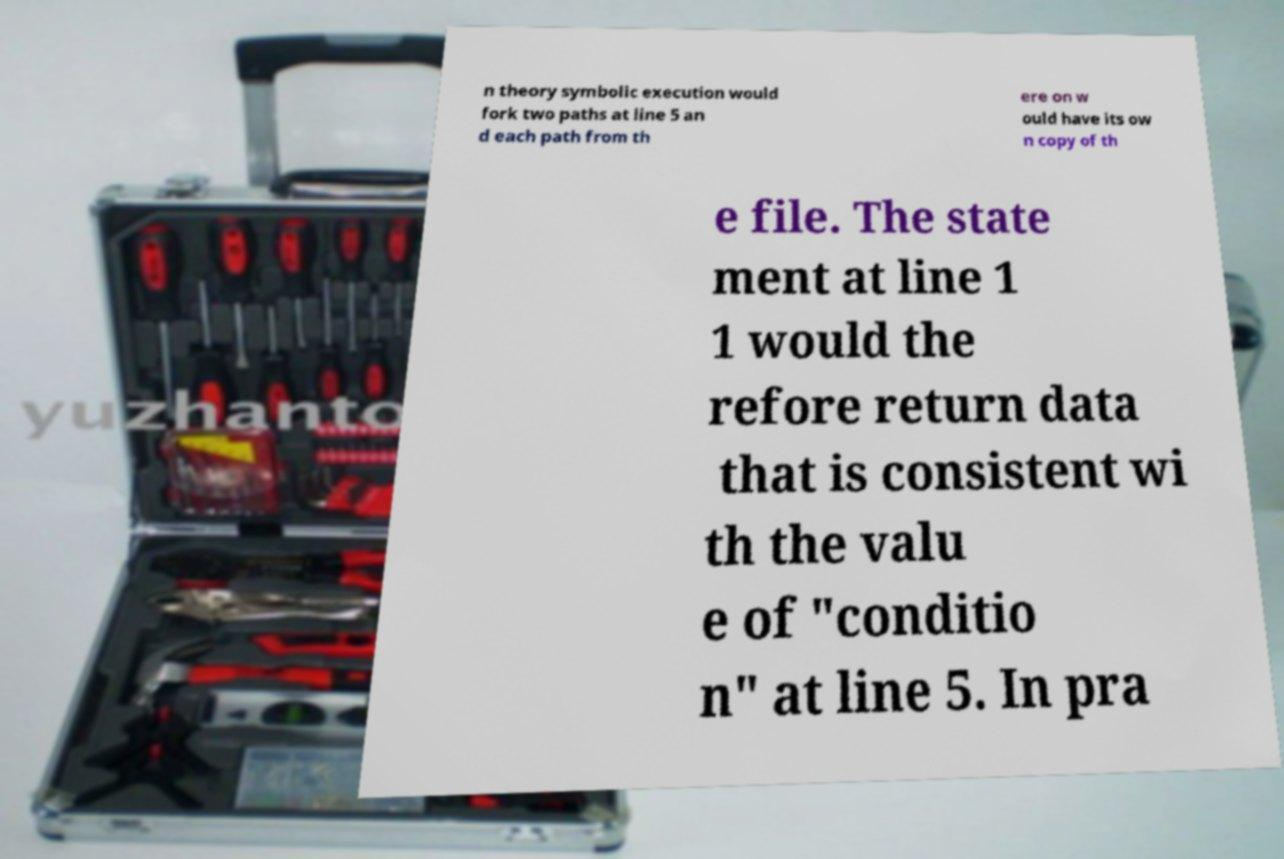Could you extract and type out the text from this image? n theory symbolic execution would fork two paths at line 5 an d each path from th ere on w ould have its ow n copy of th e file. The state ment at line 1 1 would the refore return data that is consistent wi th the valu e of "conditio n" at line 5. In pra 